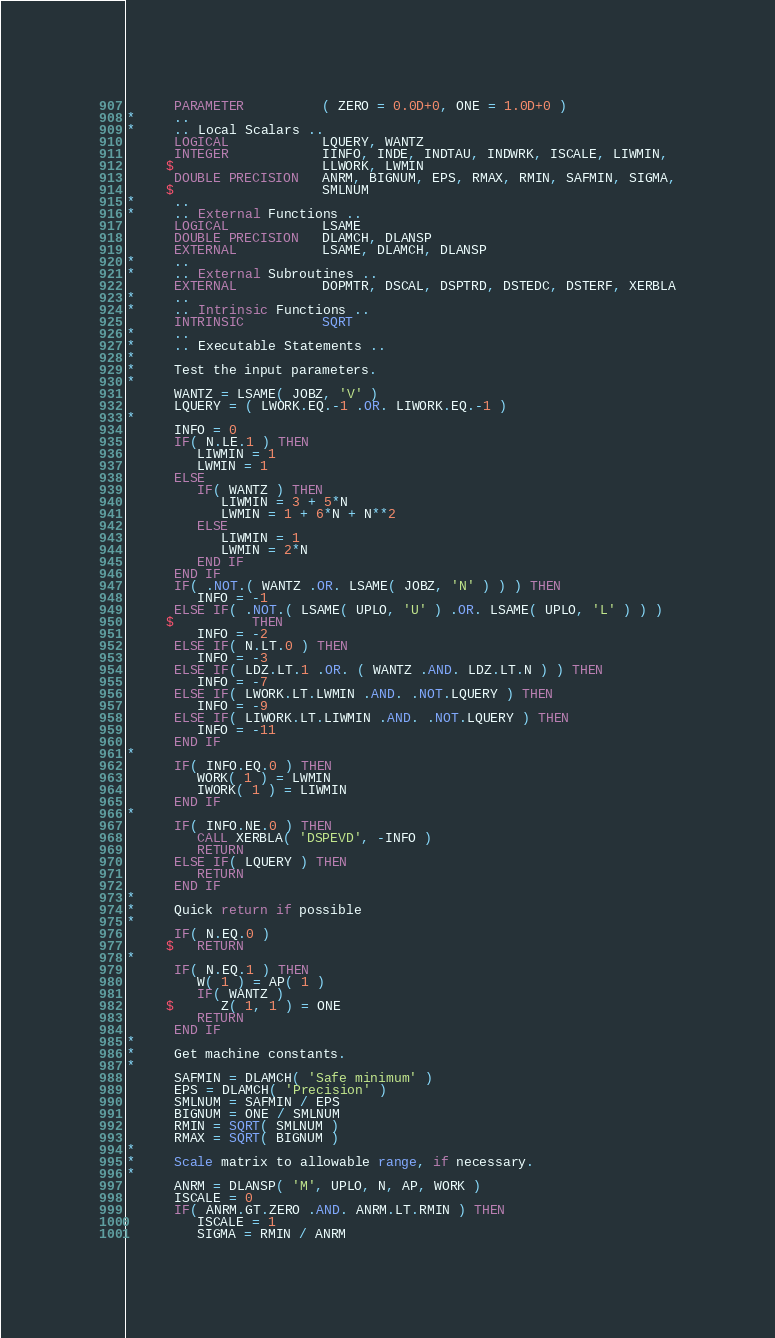Convert code to text. <code><loc_0><loc_0><loc_500><loc_500><_FORTRAN_>      PARAMETER          ( ZERO = 0.0D+0, ONE = 1.0D+0 )
*     ..
*     .. Local Scalars ..
      LOGICAL            LQUERY, WANTZ
      INTEGER            IINFO, INDE, INDTAU, INDWRK, ISCALE, LIWMIN,
     $                   LLWORK, LWMIN
      DOUBLE PRECISION   ANRM, BIGNUM, EPS, RMAX, RMIN, SAFMIN, SIGMA,
     $                   SMLNUM
*     ..
*     .. External Functions ..
      LOGICAL            LSAME
      DOUBLE PRECISION   DLAMCH, DLANSP
      EXTERNAL           LSAME, DLAMCH, DLANSP
*     ..
*     .. External Subroutines ..
      EXTERNAL           DOPMTR, DSCAL, DSPTRD, DSTEDC, DSTERF, XERBLA
*     ..
*     .. Intrinsic Functions ..
      INTRINSIC          SQRT
*     ..
*     .. Executable Statements ..
*
*     Test the input parameters.
*
      WANTZ = LSAME( JOBZ, 'V' )
      LQUERY = ( LWORK.EQ.-1 .OR. LIWORK.EQ.-1 )
*
      INFO = 0
      IF( N.LE.1 ) THEN
         LIWMIN = 1
         LWMIN = 1
      ELSE
         IF( WANTZ ) THEN
            LIWMIN = 3 + 5*N
            LWMIN = 1 + 6*N + N**2
         ELSE
            LIWMIN = 1
            LWMIN = 2*N
         END IF
      END IF
      IF( .NOT.( WANTZ .OR. LSAME( JOBZ, 'N' ) ) ) THEN
         INFO = -1
      ELSE IF( .NOT.( LSAME( UPLO, 'U' ) .OR. LSAME( UPLO, 'L' ) ) )
     $          THEN
         INFO = -2
      ELSE IF( N.LT.0 ) THEN
         INFO = -3
      ELSE IF( LDZ.LT.1 .OR. ( WANTZ .AND. LDZ.LT.N ) ) THEN
         INFO = -7
      ELSE IF( LWORK.LT.LWMIN .AND. .NOT.LQUERY ) THEN
         INFO = -9
      ELSE IF( LIWORK.LT.LIWMIN .AND. .NOT.LQUERY ) THEN
         INFO = -11
      END IF
*
      IF( INFO.EQ.0 ) THEN
         WORK( 1 ) = LWMIN
         IWORK( 1 ) = LIWMIN
      END IF
*
      IF( INFO.NE.0 ) THEN
         CALL XERBLA( 'DSPEVD', -INFO )
         RETURN
      ELSE IF( LQUERY ) THEN
         RETURN
      END IF
*
*     Quick return if possible
*
      IF( N.EQ.0 )
     $   RETURN
*
      IF( N.EQ.1 ) THEN
         W( 1 ) = AP( 1 )
         IF( WANTZ )
     $      Z( 1, 1 ) = ONE
         RETURN
      END IF
*
*     Get machine constants.
*
      SAFMIN = DLAMCH( 'Safe minimum' )
      EPS = DLAMCH( 'Precision' )
      SMLNUM = SAFMIN / EPS
      BIGNUM = ONE / SMLNUM
      RMIN = SQRT( SMLNUM )
      RMAX = SQRT( BIGNUM )
*
*     Scale matrix to allowable range, if necessary.
*
      ANRM = DLANSP( 'M', UPLO, N, AP, WORK )
      ISCALE = 0
      IF( ANRM.GT.ZERO .AND. ANRM.LT.RMIN ) THEN
         ISCALE = 1
         SIGMA = RMIN / ANRM</code> 